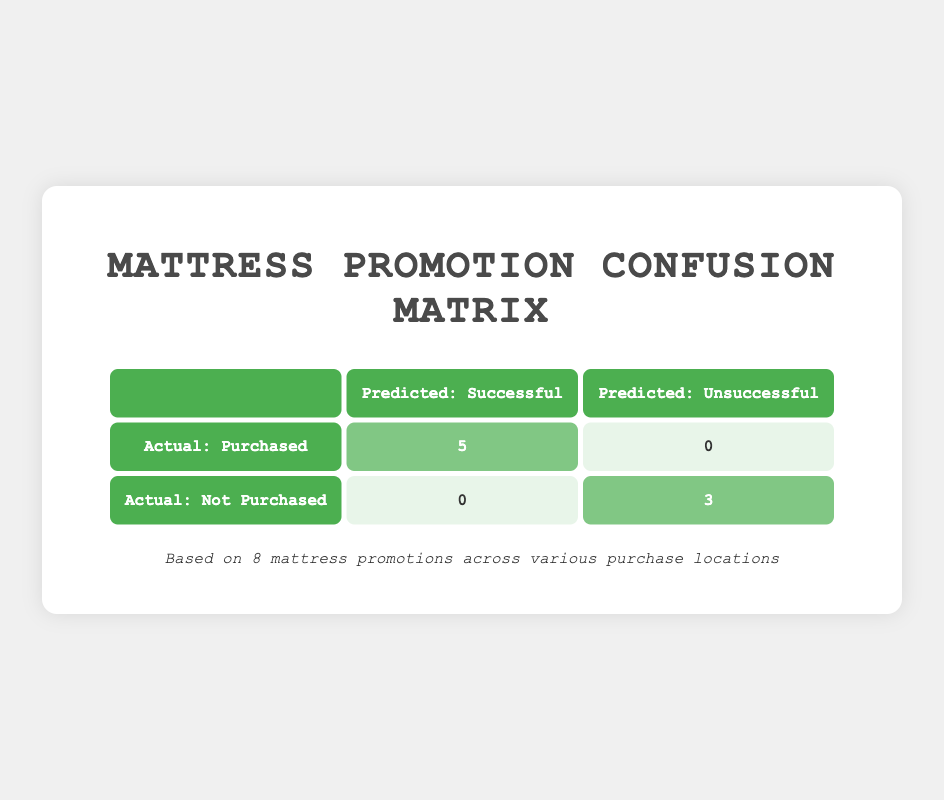What is the total number of Successful promotions leading to purchases? From the table, we see that there are 5 instances where the actual outcome is "Purchased" and the predicted outcome is "Successful." These successes come from the "Online (Amazon)," "Physical Store (IKEA)," "Physical Store (Mattress Firm)," "Physical Store (Target)," and "Online (eBay)."
Answer: 5 How many promotions were marked as Unsuccessful? The table indicates there are 3 instances represented under "Not Purchased," and they all have the prediction labeled as "Unsuccessful." They are from "Online (Walmart)," "Online (Wayfair)," and "Physical Store (Sleep Number)."
Answer: 3 Did any Unsuccessful promotions lead to purchases? Looking at the table, we see that no promotions that were marked as "Unsuccessful" resulted in a purchase, as all "Not Purchased" entries link to "Unsuccessful."
Answer: No What is the ratio of Successful promotions to Unsuccessful promotions? There are 5 Successful promotions (linked to Purchases) and 3 Unsuccessful promotions (linked to Not Purchases). The ratio is therefore 5:3, which is calculated by dividing the number of Successful by Unsuccessful promotions.
Answer: 5:3 What percentage of promotions were Successful overall? Out of the 8 total promotions, 5 were Successful. To calculate the percentage, we do (5 Successful / 8 total) * 100, which yields 62.5%.
Answer: 62.5% 